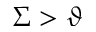<formula> <loc_0><loc_0><loc_500><loc_500>\Sigma > \vartheta</formula> 